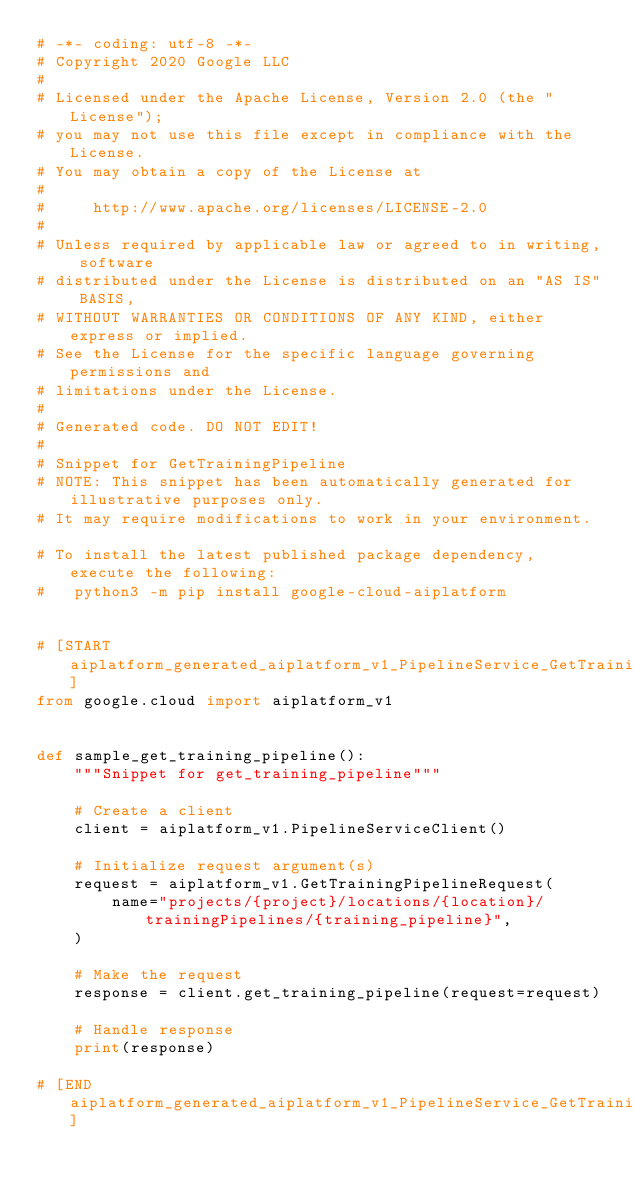Convert code to text. <code><loc_0><loc_0><loc_500><loc_500><_Python_># -*- coding: utf-8 -*-
# Copyright 2020 Google LLC
#
# Licensed under the Apache License, Version 2.0 (the "License");
# you may not use this file except in compliance with the License.
# You may obtain a copy of the License at
#
#     http://www.apache.org/licenses/LICENSE-2.0
#
# Unless required by applicable law or agreed to in writing, software
# distributed under the License is distributed on an "AS IS" BASIS,
# WITHOUT WARRANTIES OR CONDITIONS OF ANY KIND, either express or implied.
# See the License for the specific language governing permissions and
# limitations under the License.
#
# Generated code. DO NOT EDIT!
#
# Snippet for GetTrainingPipeline
# NOTE: This snippet has been automatically generated for illustrative purposes only.
# It may require modifications to work in your environment.

# To install the latest published package dependency, execute the following:
#   python3 -m pip install google-cloud-aiplatform


# [START aiplatform_generated_aiplatform_v1_PipelineService_GetTrainingPipeline_sync]
from google.cloud import aiplatform_v1


def sample_get_training_pipeline():
    """Snippet for get_training_pipeline"""

    # Create a client
    client = aiplatform_v1.PipelineServiceClient()

    # Initialize request argument(s)
    request = aiplatform_v1.GetTrainingPipelineRequest(
        name="projects/{project}/locations/{location}/trainingPipelines/{training_pipeline}",
    )

    # Make the request
    response = client.get_training_pipeline(request=request)

    # Handle response
    print(response)

# [END aiplatform_generated_aiplatform_v1_PipelineService_GetTrainingPipeline_sync]
</code> 